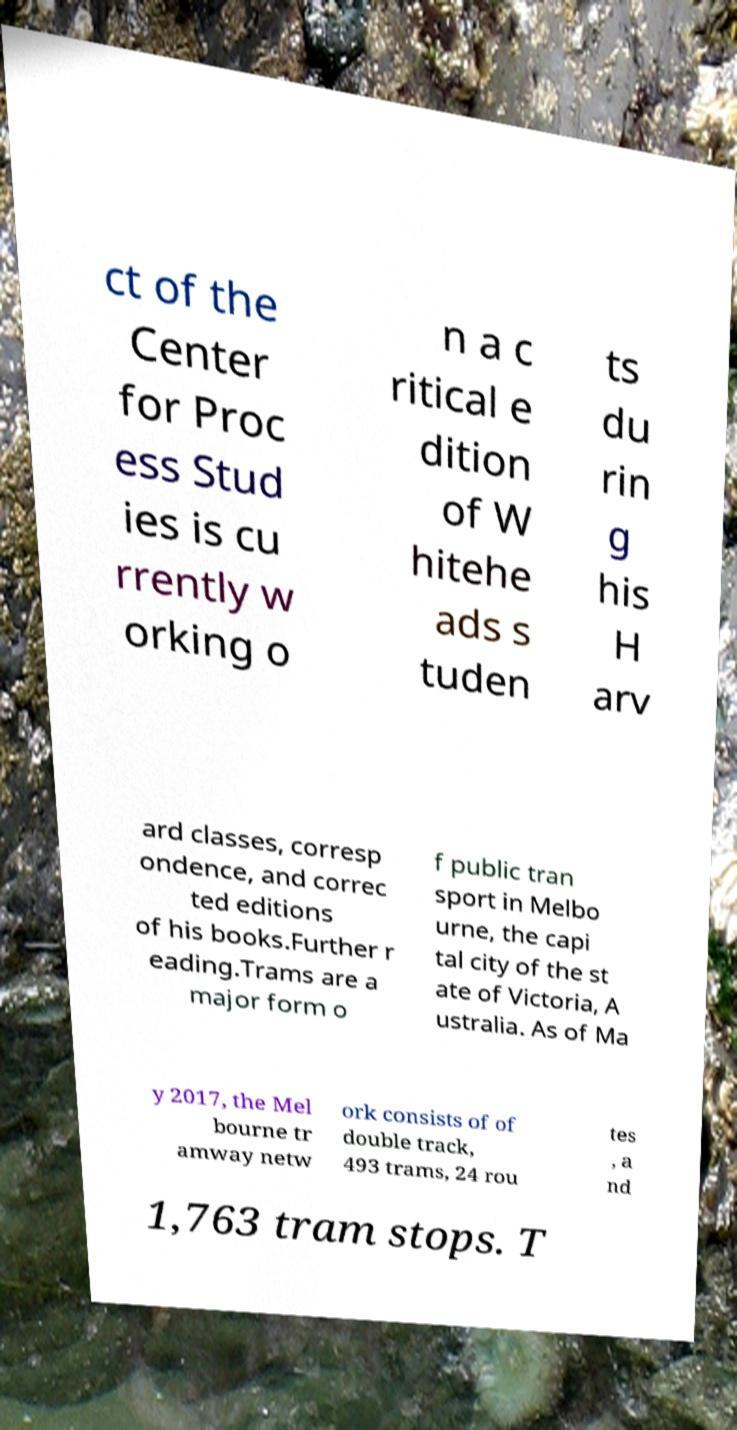Can you accurately transcribe the text from the provided image for me? ct of the Center for Proc ess Stud ies is cu rrently w orking o n a c ritical e dition of W hitehe ads s tuden ts du rin g his H arv ard classes, corresp ondence, and correc ted editions of his books.Further r eading.Trams are a major form o f public tran sport in Melbo urne, the capi tal city of the st ate of Victoria, A ustralia. As of Ma y 2017, the Mel bourne tr amway netw ork consists of of double track, 493 trams, 24 rou tes , a nd 1,763 tram stops. T 